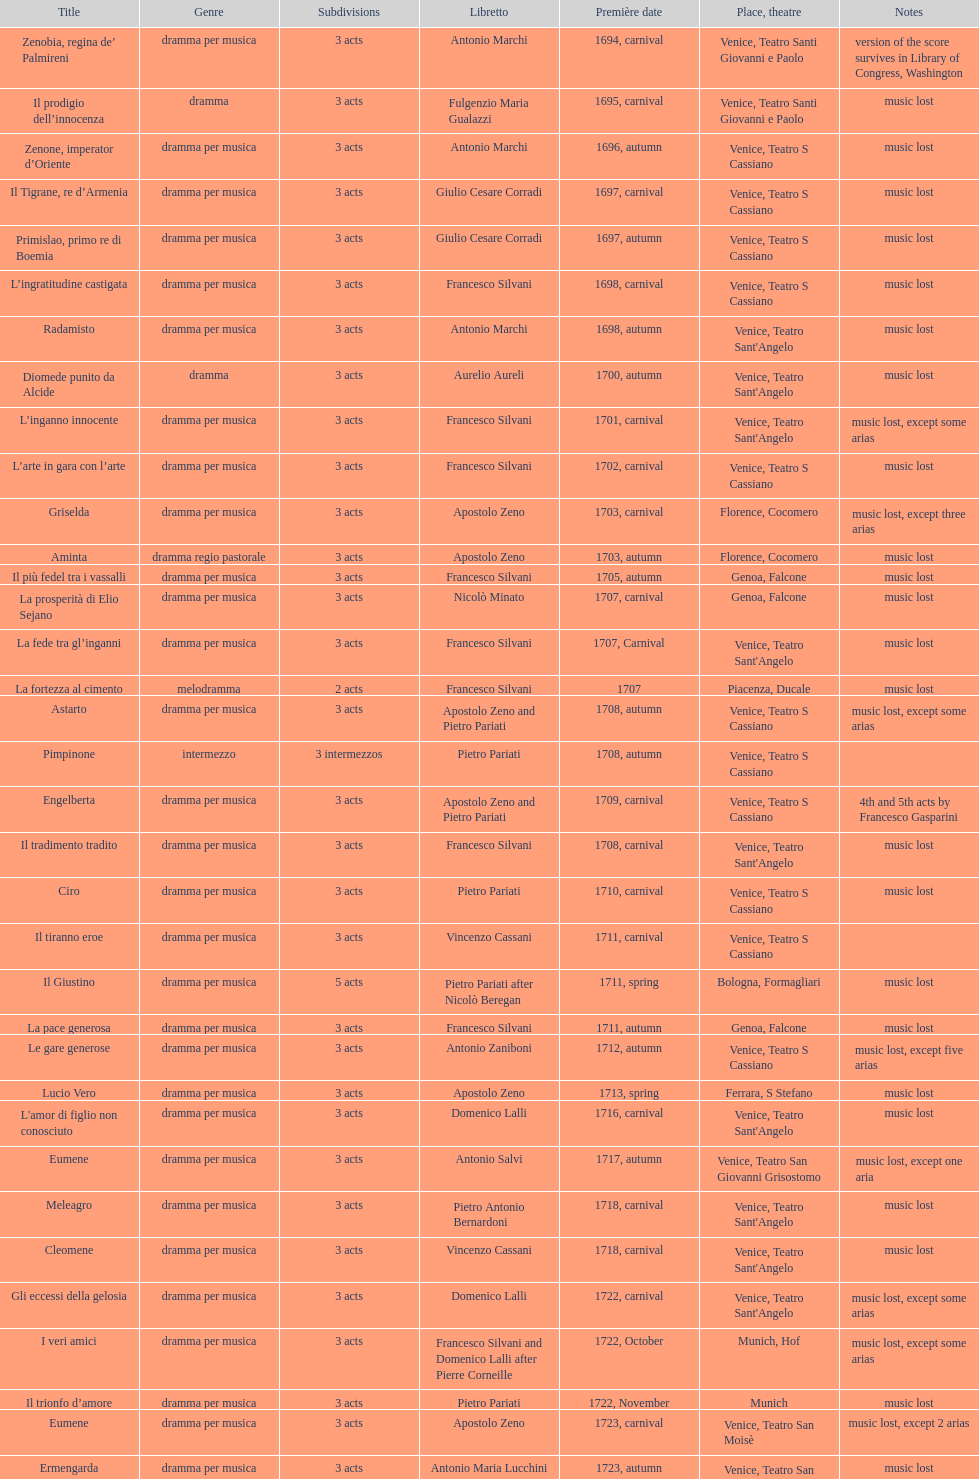How many operas on this list have 3 or more acts? 51. Give me the full table as a dictionary. {'header': ['Title', 'Genre', 'Sub\xaddivisions', 'Libretto', 'Première date', 'Place, theatre', 'Notes'], 'rows': [['Zenobia, regina de’ Palmireni', 'dramma per musica', '3 acts', 'Antonio Marchi', '1694, carnival', 'Venice, Teatro Santi Giovanni e Paolo', 'version of the score survives in Library of Congress, Washington'], ['Il prodigio dell’innocenza', 'dramma', '3 acts', 'Fulgenzio Maria Gualazzi', '1695, carnival', 'Venice, Teatro Santi Giovanni e Paolo', 'music lost'], ['Zenone, imperator d’Oriente', 'dramma per musica', '3 acts', 'Antonio Marchi', '1696, autumn', 'Venice, Teatro S Cassiano', 'music lost'], ['Il Tigrane, re d’Armenia', 'dramma per musica', '3 acts', 'Giulio Cesare Corradi', '1697, carnival', 'Venice, Teatro S Cassiano', 'music lost'], ['Primislao, primo re di Boemia', 'dramma per musica', '3 acts', 'Giulio Cesare Corradi', '1697, autumn', 'Venice, Teatro S Cassiano', 'music lost'], ['L’ingratitudine castigata', 'dramma per musica', '3 acts', 'Francesco Silvani', '1698, carnival', 'Venice, Teatro S Cassiano', 'music lost'], ['Radamisto', 'dramma per musica', '3 acts', 'Antonio Marchi', '1698, autumn', "Venice, Teatro Sant'Angelo", 'music lost'], ['Diomede punito da Alcide', 'dramma', '3 acts', 'Aurelio Aureli', '1700, autumn', "Venice, Teatro Sant'Angelo", 'music lost'], ['L’inganno innocente', 'dramma per musica', '3 acts', 'Francesco Silvani', '1701, carnival', "Venice, Teatro Sant'Angelo", 'music lost, except some arias'], ['L’arte in gara con l’arte', 'dramma per musica', '3 acts', 'Francesco Silvani', '1702, carnival', 'Venice, Teatro S Cassiano', 'music lost'], ['Griselda', 'dramma per musica', '3 acts', 'Apostolo Zeno', '1703, carnival', 'Florence, Cocomero', 'music lost, except three arias'], ['Aminta', 'dramma regio pastorale', '3 acts', 'Apostolo Zeno', '1703, autumn', 'Florence, Cocomero', 'music lost'], ['Il più fedel tra i vassalli', 'dramma per musica', '3 acts', 'Francesco Silvani', '1705, autumn', 'Genoa, Falcone', 'music lost'], ['La prosperità di Elio Sejano', 'dramma per musica', '3 acts', 'Nicolò Minato', '1707, carnival', 'Genoa, Falcone', 'music lost'], ['La fede tra gl’inganni', 'dramma per musica', '3 acts', 'Francesco Silvani', '1707, Carnival', "Venice, Teatro Sant'Angelo", 'music lost'], ['La fortezza al cimento', 'melodramma', '2 acts', 'Francesco Silvani', '1707', 'Piacenza, Ducale', 'music lost'], ['Astarto', 'dramma per musica', '3 acts', 'Apostolo Zeno and Pietro Pariati', '1708, autumn', 'Venice, Teatro S Cassiano', 'music lost, except some arias'], ['Pimpinone', 'intermezzo', '3 intermezzos', 'Pietro Pariati', '1708, autumn', 'Venice, Teatro S Cassiano', ''], ['Engelberta', 'dramma per musica', '3 acts', 'Apostolo Zeno and Pietro Pariati', '1709, carnival', 'Venice, Teatro S Cassiano', '4th and 5th acts by Francesco Gasparini'], ['Il tradimento tradito', 'dramma per musica', '3 acts', 'Francesco Silvani', '1708, carnival', "Venice, Teatro Sant'Angelo", 'music lost'], ['Ciro', 'dramma per musica', '3 acts', 'Pietro Pariati', '1710, carnival', 'Venice, Teatro S Cassiano', 'music lost'], ['Il tiranno eroe', 'dramma per musica', '3 acts', 'Vincenzo Cassani', '1711, carnival', 'Venice, Teatro S Cassiano', ''], ['Il Giustino', 'dramma per musica', '5 acts', 'Pietro Pariati after Nicolò Beregan', '1711, spring', 'Bologna, Formagliari', 'music lost'], ['La pace generosa', 'dramma per musica', '3 acts', 'Francesco Silvani', '1711, autumn', 'Genoa, Falcone', 'music lost'], ['Le gare generose', 'dramma per musica', '3 acts', 'Antonio Zaniboni', '1712, autumn', 'Venice, Teatro S Cassiano', 'music lost, except five arias'], ['Lucio Vero', 'dramma per musica', '3 acts', 'Apostolo Zeno', '1713, spring', 'Ferrara, S Stefano', 'music lost'], ["L'amor di figlio non conosciuto", 'dramma per musica', '3 acts', 'Domenico Lalli', '1716, carnival', "Venice, Teatro Sant'Angelo", 'music lost'], ['Eumene', 'dramma per musica', '3 acts', 'Antonio Salvi', '1717, autumn', 'Venice, Teatro San Giovanni Grisostomo', 'music lost, except one aria'], ['Meleagro', 'dramma per musica', '3 acts', 'Pietro Antonio Bernardoni', '1718, carnival', "Venice, Teatro Sant'Angelo", 'music lost'], ['Cleomene', 'dramma per musica', '3 acts', 'Vincenzo Cassani', '1718, carnival', "Venice, Teatro Sant'Angelo", 'music lost'], ['Gli eccessi della gelosia', 'dramma per musica', '3 acts', 'Domenico Lalli', '1722, carnival', "Venice, Teatro Sant'Angelo", 'music lost, except some arias'], ['I veri amici', 'dramma per musica', '3 acts', 'Francesco Silvani and Domenico Lalli after Pierre Corneille', '1722, October', 'Munich, Hof', 'music lost, except some arias'], ['Il trionfo d’amore', 'dramma per musica', '3 acts', 'Pietro Pariati', '1722, November', 'Munich', 'music lost'], ['Eumene', 'dramma per musica', '3 acts', 'Apostolo Zeno', '1723, carnival', 'Venice, Teatro San Moisè', 'music lost, except 2 arias'], ['Ermengarda', 'dramma per musica', '3 acts', 'Antonio Maria Lucchini', '1723, autumn', 'Venice, Teatro San Moisè', 'music lost'], ['Antigono, tutore di Filippo, re di Macedonia', 'tragedia', '5 acts', 'Giovanni Piazzon', '1724, carnival', 'Venice, Teatro San Moisè', '5th act by Giovanni Porta, music lost'], ['Scipione nelle Spagne', 'dramma per musica', '3 acts', 'Apostolo Zeno', '1724, Ascension', 'Venice, Teatro San Samuele', 'music lost'], ['Laodice', 'dramma per musica', '3 acts', 'Angelo Schietti', '1724, autumn', 'Venice, Teatro San Moisè', 'music lost, except 2 arias'], ['Didone abbandonata', 'tragedia', '3 acts', 'Metastasio', '1725, carnival', 'Venice, Teatro S Cassiano', 'music lost'], ["L'impresario delle Isole Canarie", 'intermezzo', '2 acts', 'Metastasio', '1725, carnival', 'Venice, Teatro S Cassiano', 'music lost'], ['Alcina delusa da Ruggero', 'dramma per musica', '3 acts', 'Antonio Marchi', '1725, autumn', 'Venice, Teatro S Cassiano', 'music lost'], ['I rivali generosi', 'dramma per musica', '3 acts', 'Apostolo Zeno', '1725', 'Brescia, Nuovo', ''], ['La Statira', 'dramma per musica', '3 acts', 'Apostolo Zeno and Pietro Pariati', '1726, Carnival', 'Rome, Teatro Capranica', ''], ['Malsazio e Fiammetta', 'intermezzo', '', '', '1726, Carnival', 'Rome, Teatro Capranica', ''], ['Il trionfo di Armida', 'dramma per musica', '3 acts', 'Girolamo Colatelli after Torquato Tasso', '1726, autumn', 'Venice, Teatro San Moisè', 'music lost'], ['L’incostanza schernita', 'dramma comico-pastorale', '3 acts', 'Vincenzo Cassani', '1727, Ascension', 'Venice, Teatro San Samuele', 'music lost, except some arias'], ['Le due rivali in amore', 'dramma per musica', '3 acts', 'Aurelio Aureli', '1728, autumn', 'Venice, Teatro San Moisè', 'music lost'], ['Il Satrapone', 'intermezzo', '', 'Salvi', '1729', 'Parma, Omodeo', ''], ['Li stratagemmi amorosi', 'dramma per musica', '3 acts', 'F Passerini', '1730, carnival', 'Venice, Teatro San Moisè', 'music lost'], ['Elenia', 'dramma per musica', '3 acts', 'Luisa Bergalli', '1730, carnival', "Venice, Teatro Sant'Angelo", 'music lost'], ['Merope', 'dramma', '3 acts', 'Apostolo Zeno', '1731, autumn', 'Prague, Sporck Theater', 'mostly by Albinoni, music lost'], ['Il più infedel tra gli amanti', 'dramma per musica', '3 acts', 'Angelo Schietti', '1731, autumn', 'Treviso, Dolphin', 'music lost'], ['Ardelinda', 'dramma', '3 acts', 'Bartolomeo Vitturi', '1732, autumn', "Venice, Teatro Sant'Angelo", 'music lost, except five arias'], ['Candalide', 'dramma per musica', '3 acts', 'Bartolomeo Vitturi', '1734, carnival', "Venice, Teatro Sant'Angelo", 'music lost'], ['Artamene', 'dramma per musica', '3 acts', 'Bartolomeo Vitturi', '1741, carnival', "Venice, Teatro Sant'Angelo", 'music lost']]} 